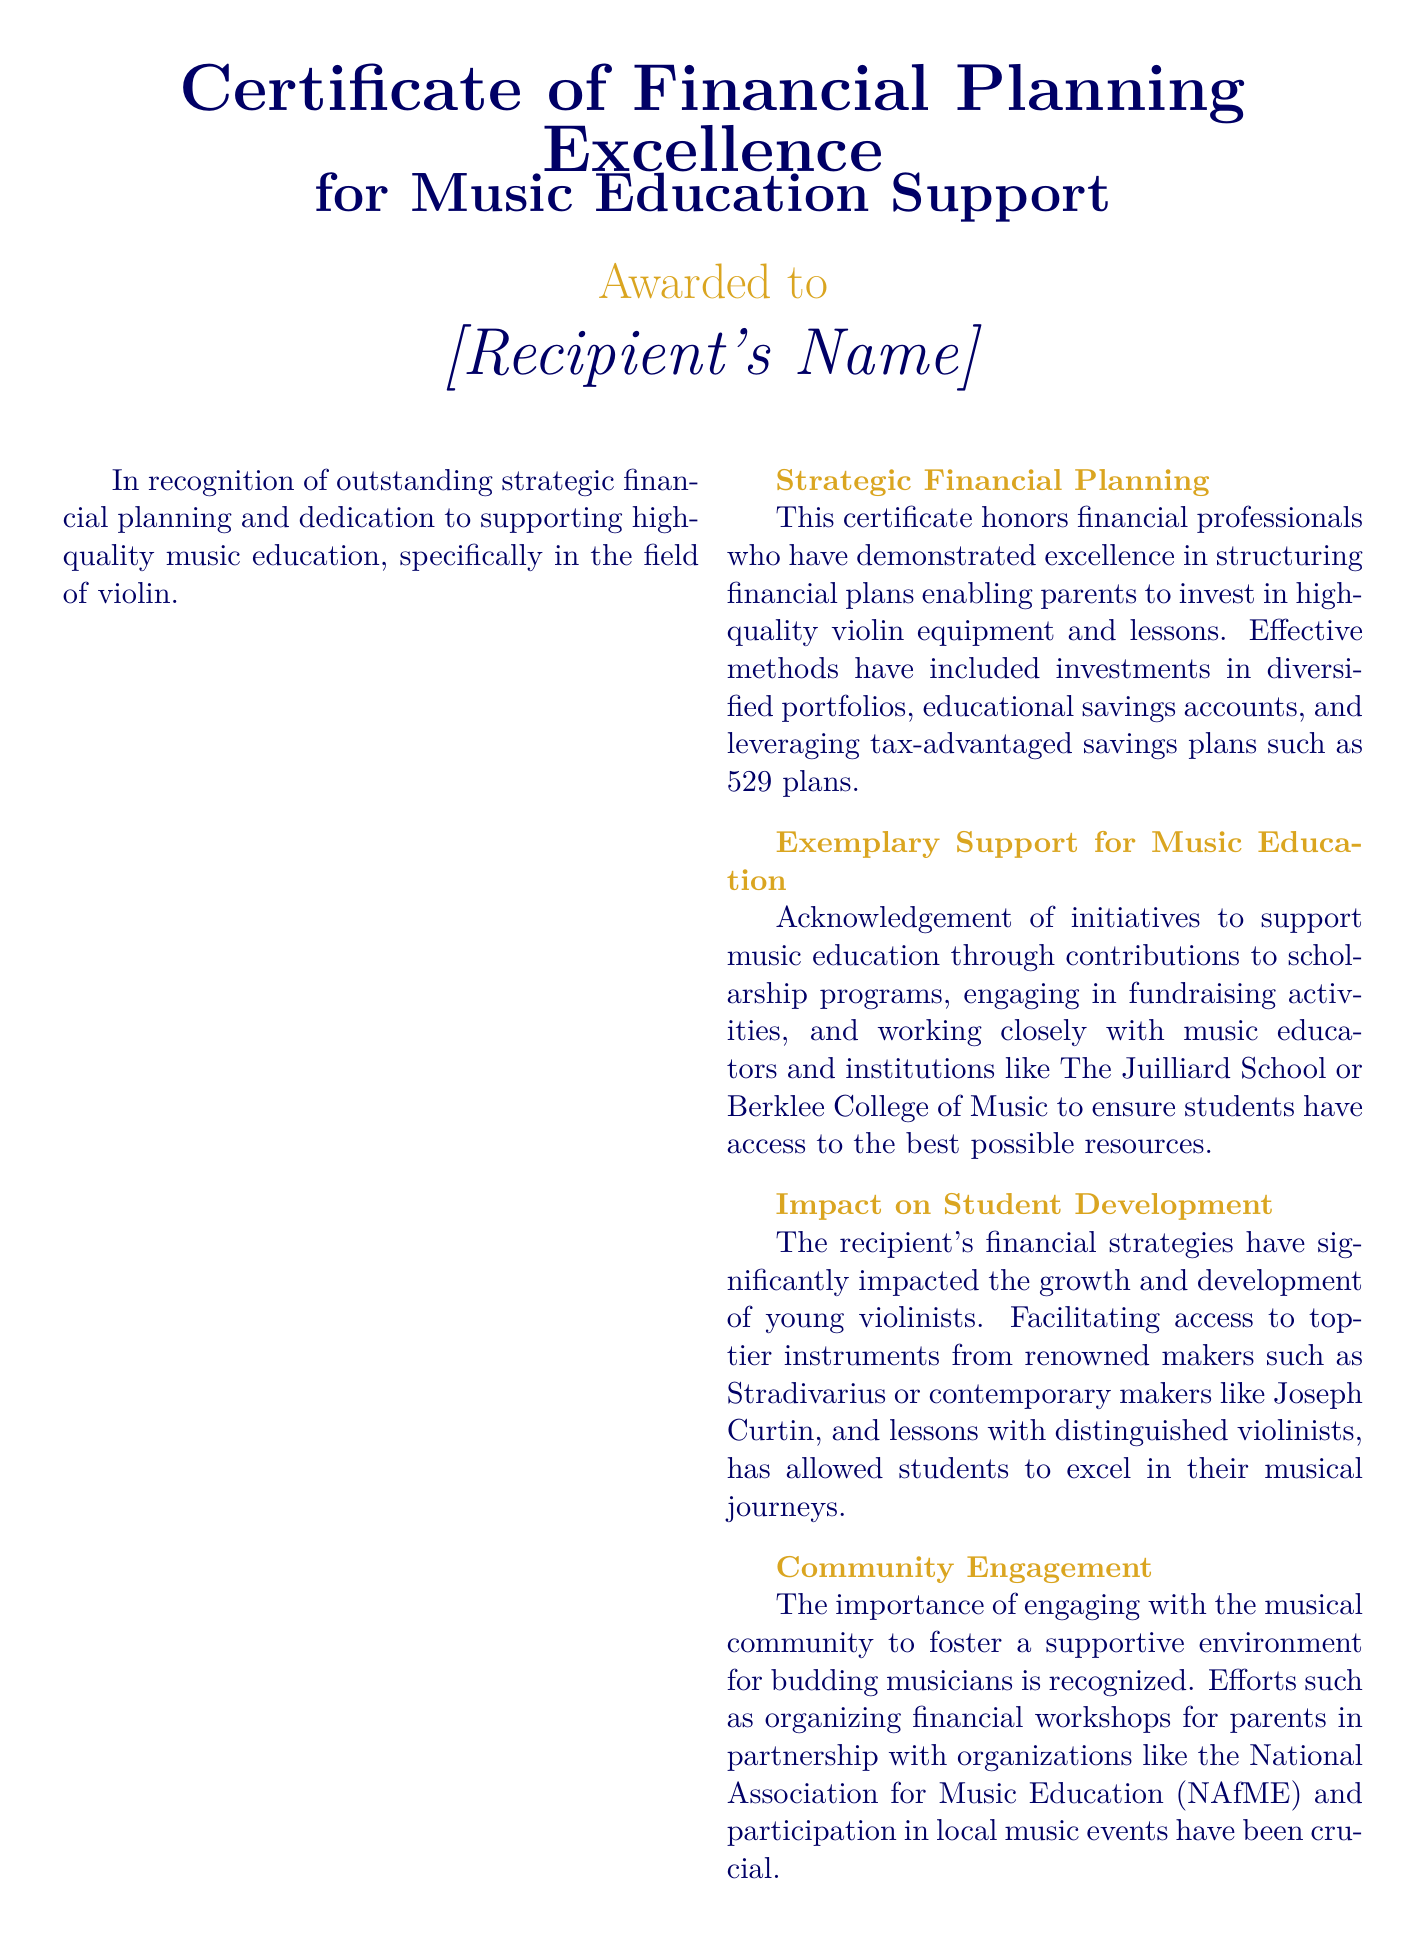What is the title of the certificate? The title of the certificate is prominently displayed at the top of the document.
Answer: Certificate of Financial Planning Excellence Who is the certificate awarded to? The recipient's name is indicated in the document.
Answer: [Recipient's Name] What is recognized by this certificate? The document specifies what outstanding achievements are being acknowledged.
Answer: Outstanding strategic financial planning Which instruments are mentioned in the document? The document highlights specific types of instruments in relation to music education.
Answer: Stradivarius What organization is mentioned for community engagement? The document references a specific organization related to music education initiatives.
Answer: National Association for Music Education (NAfME) What color is associated with the accents in the certificate? The document specifies a color used for decorative elements throughout the text.
Answer: Gold What is another name for the music education support mentioned? The document refers to additional aspects of the support provided.
Answer: Scholarship programs What date is the certificate awarded on? The date is specified but is meant to be filled in and is indicated in the document.
Answer: [Date] 